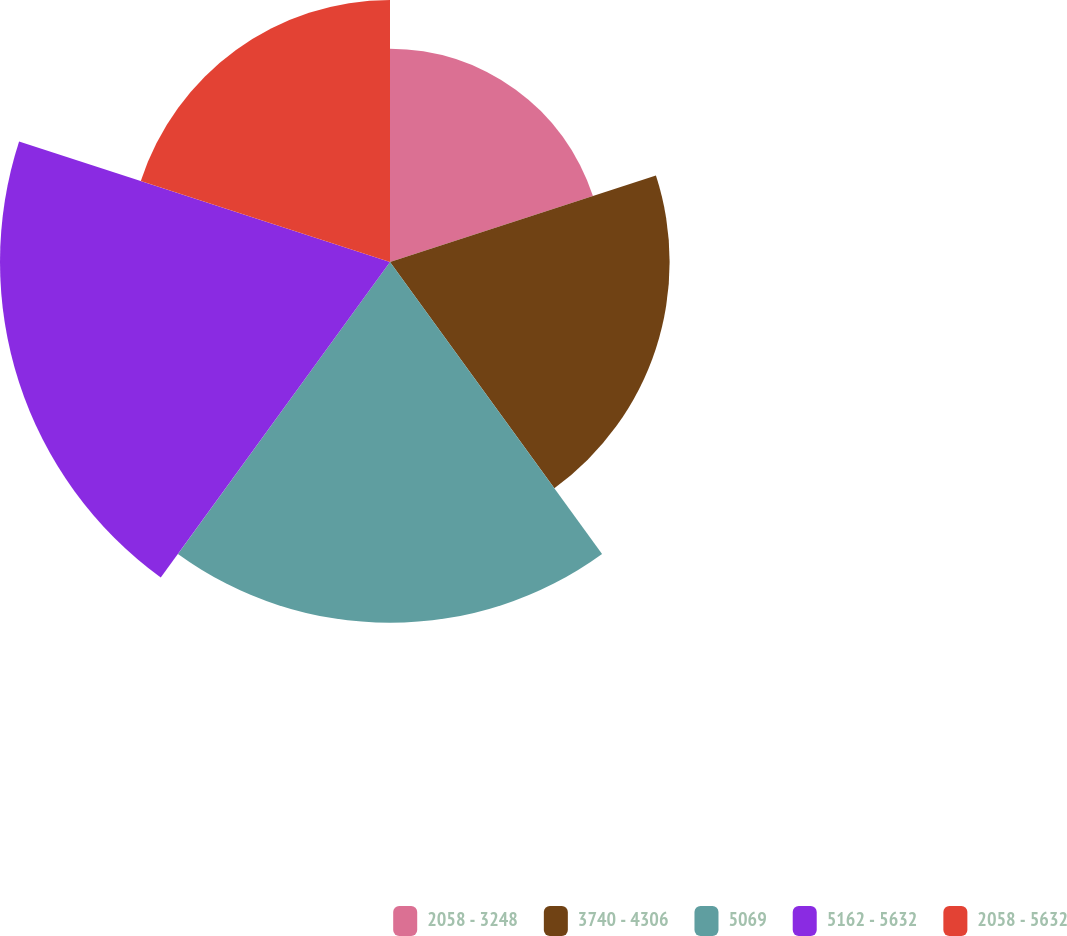Convert chart to OTSL. <chart><loc_0><loc_0><loc_500><loc_500><pie_chart><fcel>2058 - 3248<fcel>3740 - 4306<fcel>5069<fcel>5162 - 5632<fcel>2058 - 5632<nl><fcel>14.17%<fcel>18.57%<fcel>23.96%<fcel>25.9%<fcel>17.4%<nl></chart> 